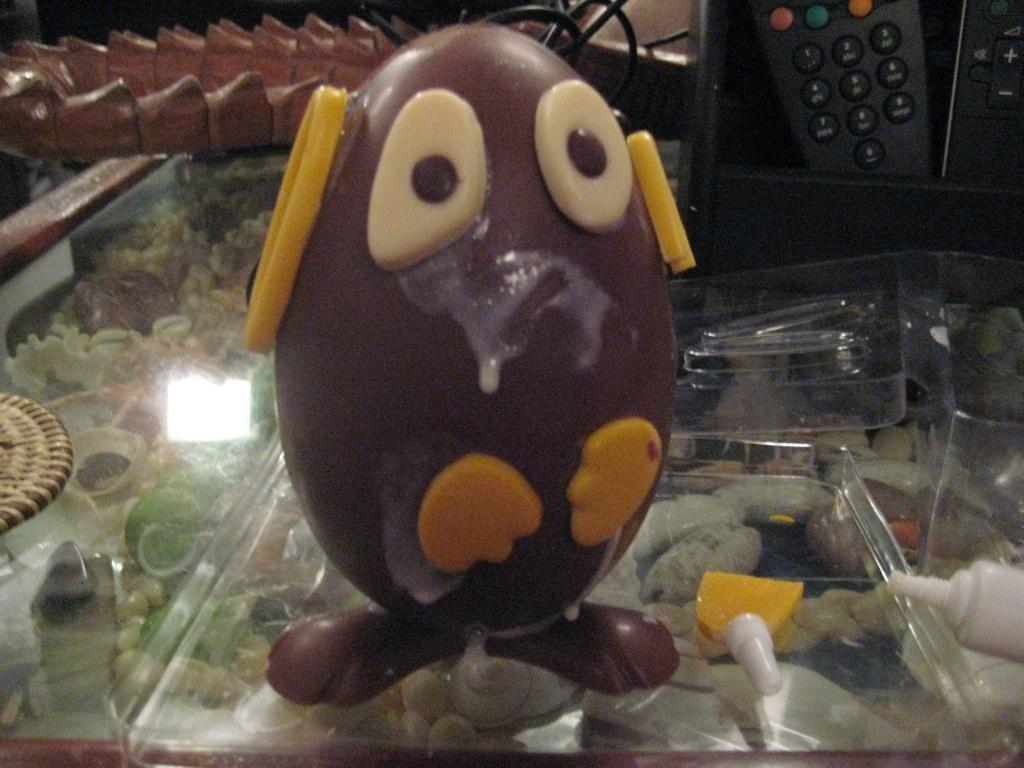Could you give a brief overview of what you see in this image? In this image we can see a food item on a glass surface. Also there is a tube. Through the glass surface we can see many items. In the back there is a remote. Also there are few other objects. 